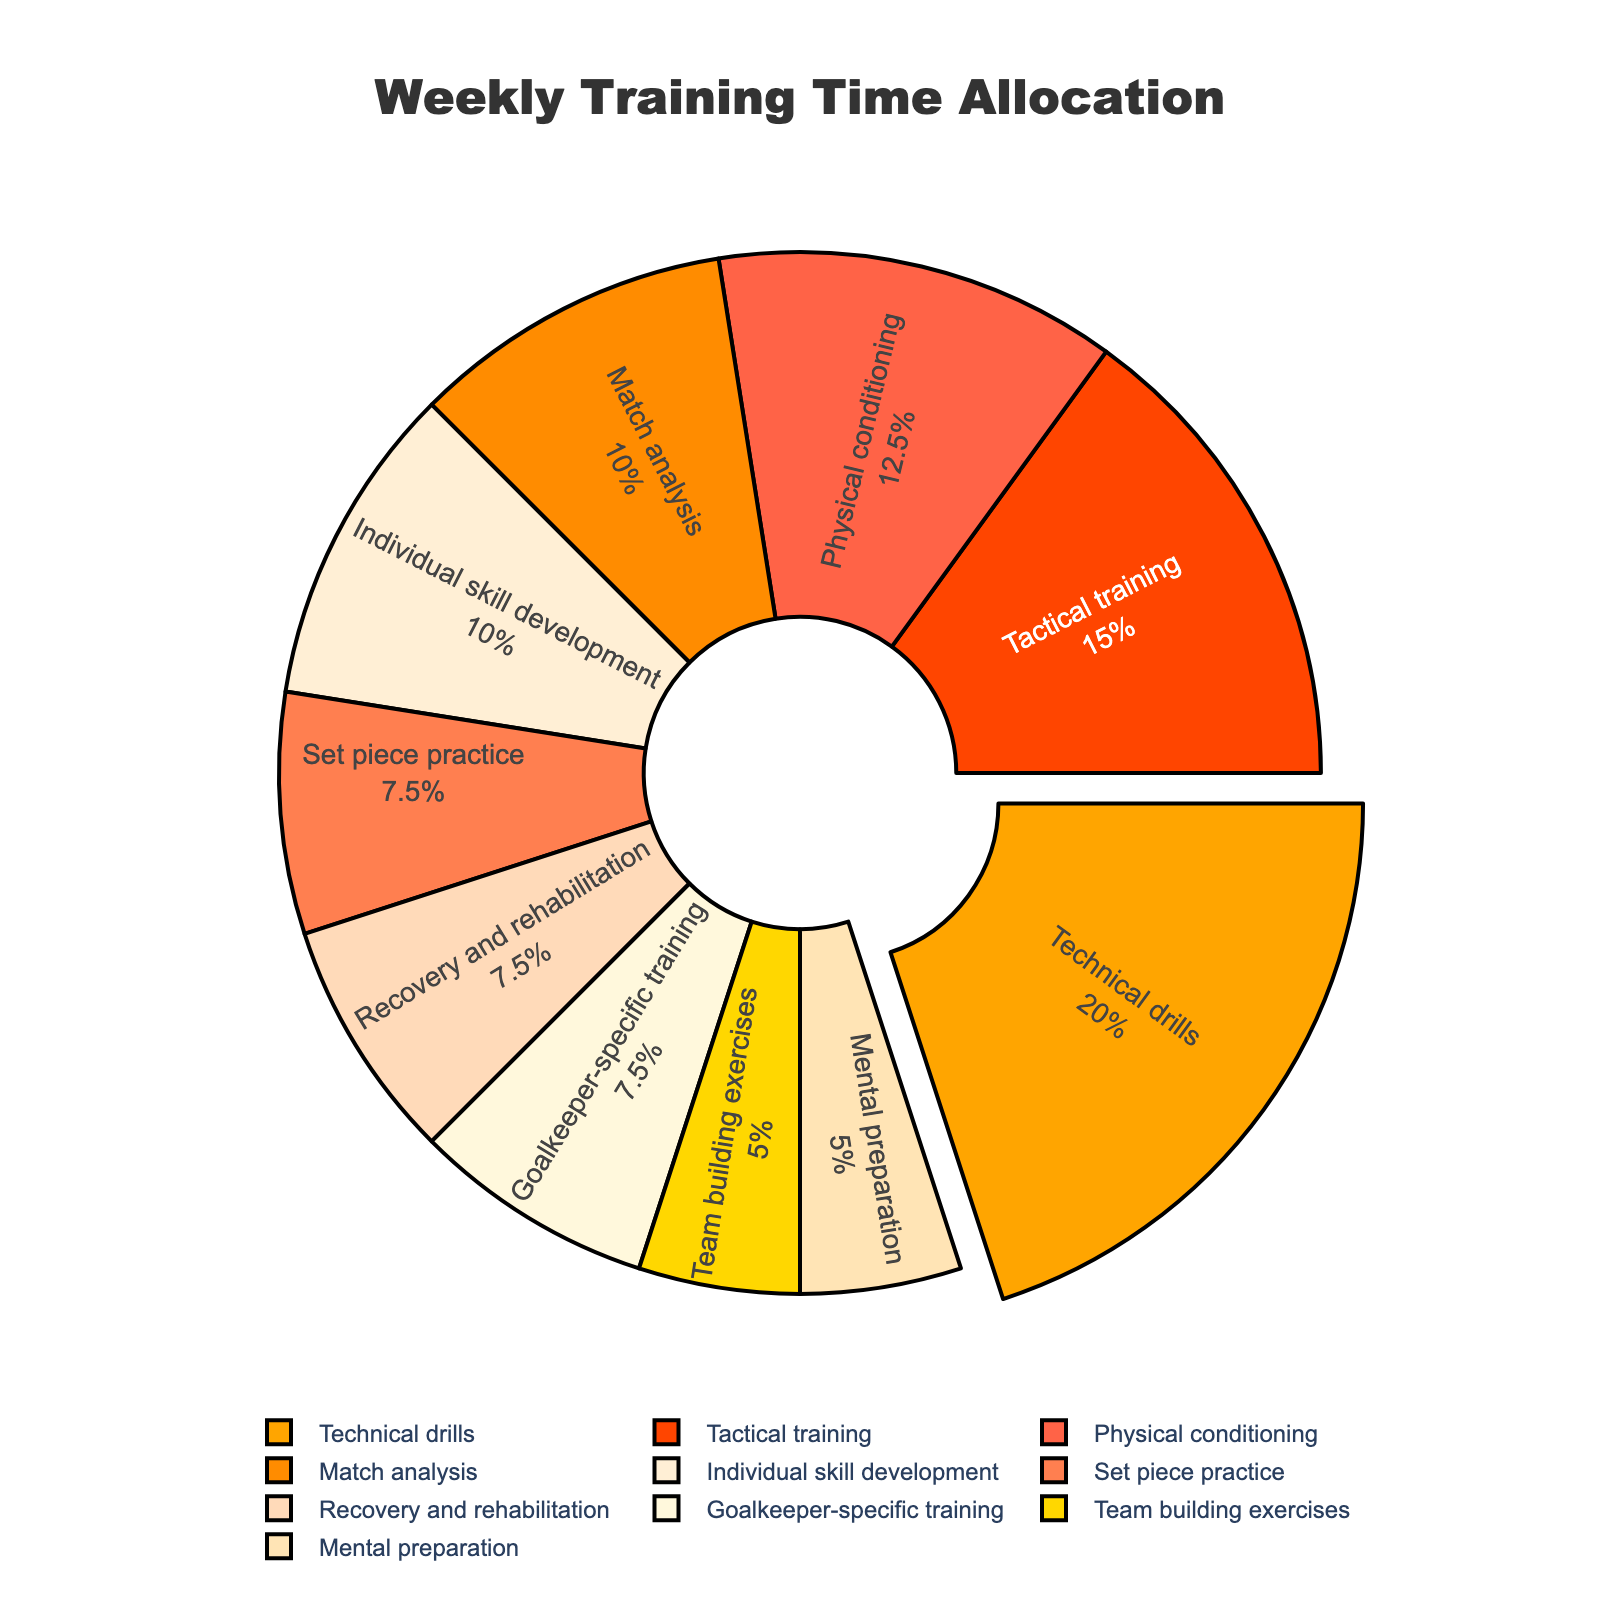What's the total time allocated to training in a typical week? Sum all the hours for each skill: 8 + 6 + 5 + 3 + 4 + 2 + 3 + 2 + 4 + 3 = 40 hours
Answer: 40 hours Which skill has the highest allocation of training time, and how much is it? The skill with the largest segment pulled out is the one with the most hours. "Technical drills" is this skill with 8 hours.
Answer: Technical drills, 8 hours How much more time is spent on Technical drills compared to Team building exercises? Technical drills have 8 hours, and Team building exercises have 2 hours. The difference is 8 - 2 = 6 hours.
Answer: 6 hours What percentage of total weekly training is devoted to Tactical training? Total hours are 40. Tactical training takes up 6 hours. The percentage is (6 / 40) * 100 = 15%.
Answer: 15% Which skills have an equal allocation of training time? By examining the sizes of the segments, we see that Set piece practice, Recovery and rehabilitation, and Goalkeeper-specific training each have 3 hours. Mental preparation and Team building exercises each have 2 hours.
Answer: Set piece practice, Recovery and rehabilitation, Goalkeeper-specific training; Mental preparation, Team building exercises How much less time is spent on Match analysis compared to all other skills combined? Total time is 40 hours. Match analysis takes 4 hours. Time spent on other skills is 40 - 4 = 36 hours. Difference is 36 - 4 = 32 hours.
Answer: 32 hours What's the ratio of hours spent on Physical conditioning to hours spent on Individual skill development? Physical conditioning has 5 hours, and Individual skill development has 4 hours. The ratio is 5:4.
Answer: 5:4 By how many hours does Tactical training exceed the sum of Mental preparation and Team building exercises? Mental preparation is 2 hours; Team building exercises is 2 hours; their sum is 2 + 2 = 4 hours. Tactical training is 6 hours. Difference is 6 - 4 = 2 hours.
Answer: 2 hours What is the difference in allocation between the skill with the highest and the skill with the lowest allocation? The highest is Technical drills (8 hours) and the lowest is Team building exercises and Mental preparation (2 hours each). Difference is 8 - 2 = 6 hours.
Answer: 6 hours How much time is devoted to all types of conditioning (Physical conditioning and Recovery and rehabilitation)? Physical conditioning is 5 hours, Recovery and rehabilitation is 3 hours. Total is 5 + 3 = 8 hours.
Answer: 8 hours 